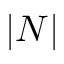Convert formula to latex. <formula><loc_0><loc_0><loc_500><loc_500>| N |</formula> 